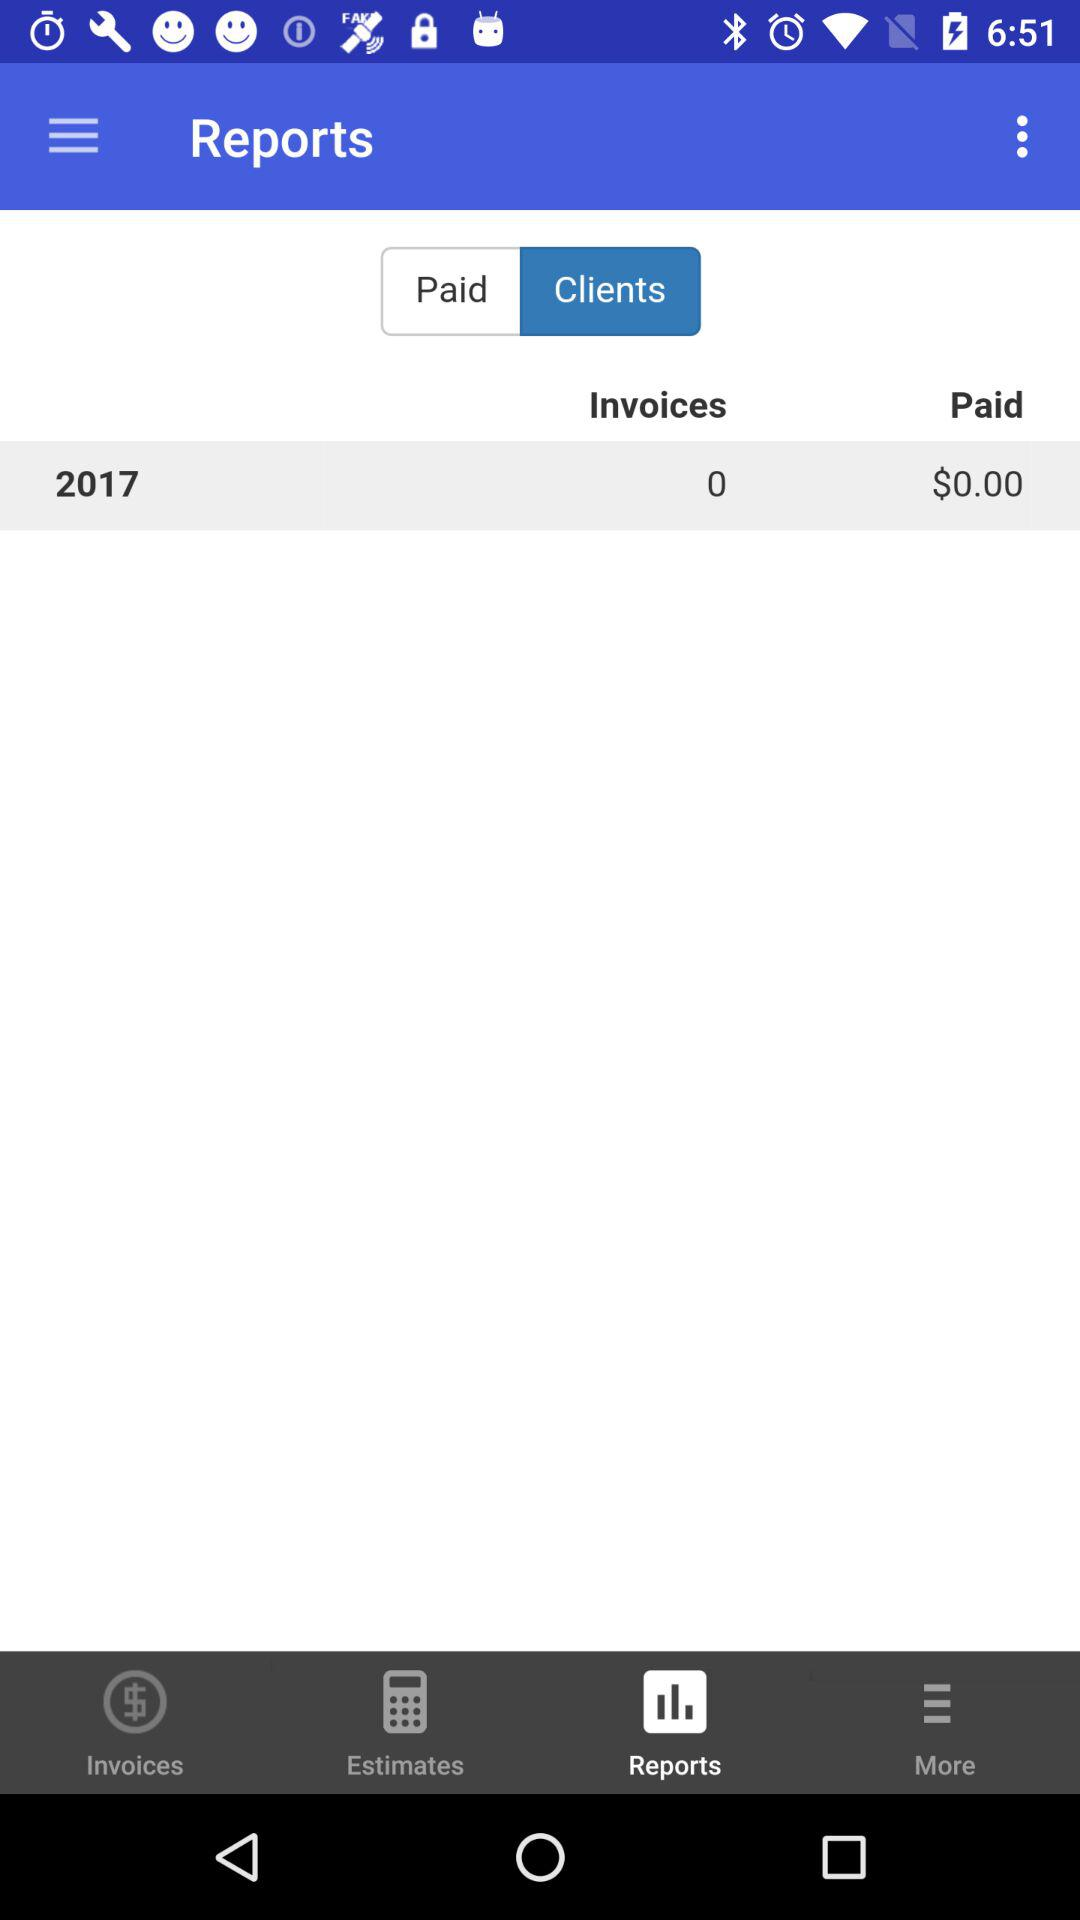What amount is paid for 2017? The amount paid for 2017 is $0. 